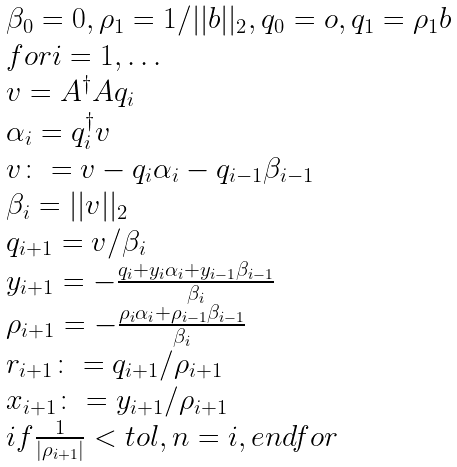Convert formula to latex. <formula><loc_0><loc_0><loc_500><loc_500>\begin{array} { l } \beta _ { 0 } = 0 , \rho _ { 1 } = 1 / | | b | | _ { 2 } , q _ { 0 } = o , q _ { 1 } = \rho _ { 1 } b \\ f o r i = 1 , \dots \\ v = A ^ { \dag } A q _ { i } \\ \alpha _ { i } = q _ { i } ^ { \dag } v \\ v \colon = v - q _ { i } \alpha _ { i } - q _ { i - 1 } \beta _ { i - 1 } \\ \beta _ { i } = | | v | | _ { 2 } \\ q _ { i + 1 } = v / \beta _ { i } \\ y _ { i + 1 } = - \frac { q _ { i } + y _ { i } \alpha _ { i } + y _ { i - 1 } \beta _ { i - 1 } } { \beta _ { i } } \\ \rho _ { i + 1 } = - \frac { \rho _ { i } \alpha _ { i } + \rho _ { i - 1 } \beta _ { i - 1 } } { \beta _ { i } } \\ r _ { i + 1 } \colon = q _ { i + 1 } / \rho _ { i + 1 } \\ x _ { i + 1 } \colon = y _ { i + 1 } / \rho _ { i + 1 } \\ i f \frac { 1 } { | \rho _ { i + 1 } | } < t o l , n = i , e n d f o r \\ \end{array}</formula> 